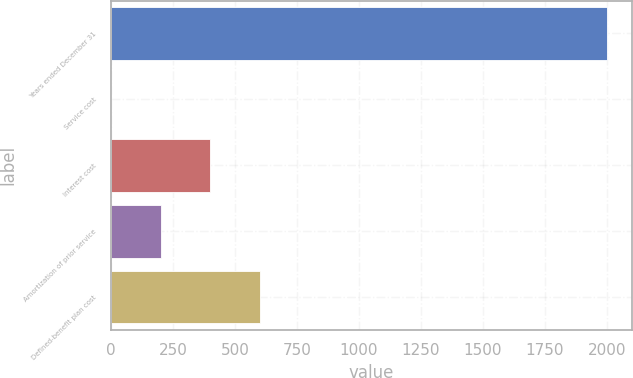Convert chart to OTSL. <chart><loc_0><loc_0><loc_500><loc_500><bar_chart><fcel>Years ended December 31<fcel>Service cost<fcel>Interest cost<fcel>Amortization of prior service<fcel>Defined-benefit plan cost<nl><fcel>2003<fcel>0.2<fcel>400.76<fcel>200.48<fcel>601.04<nl></chart> 